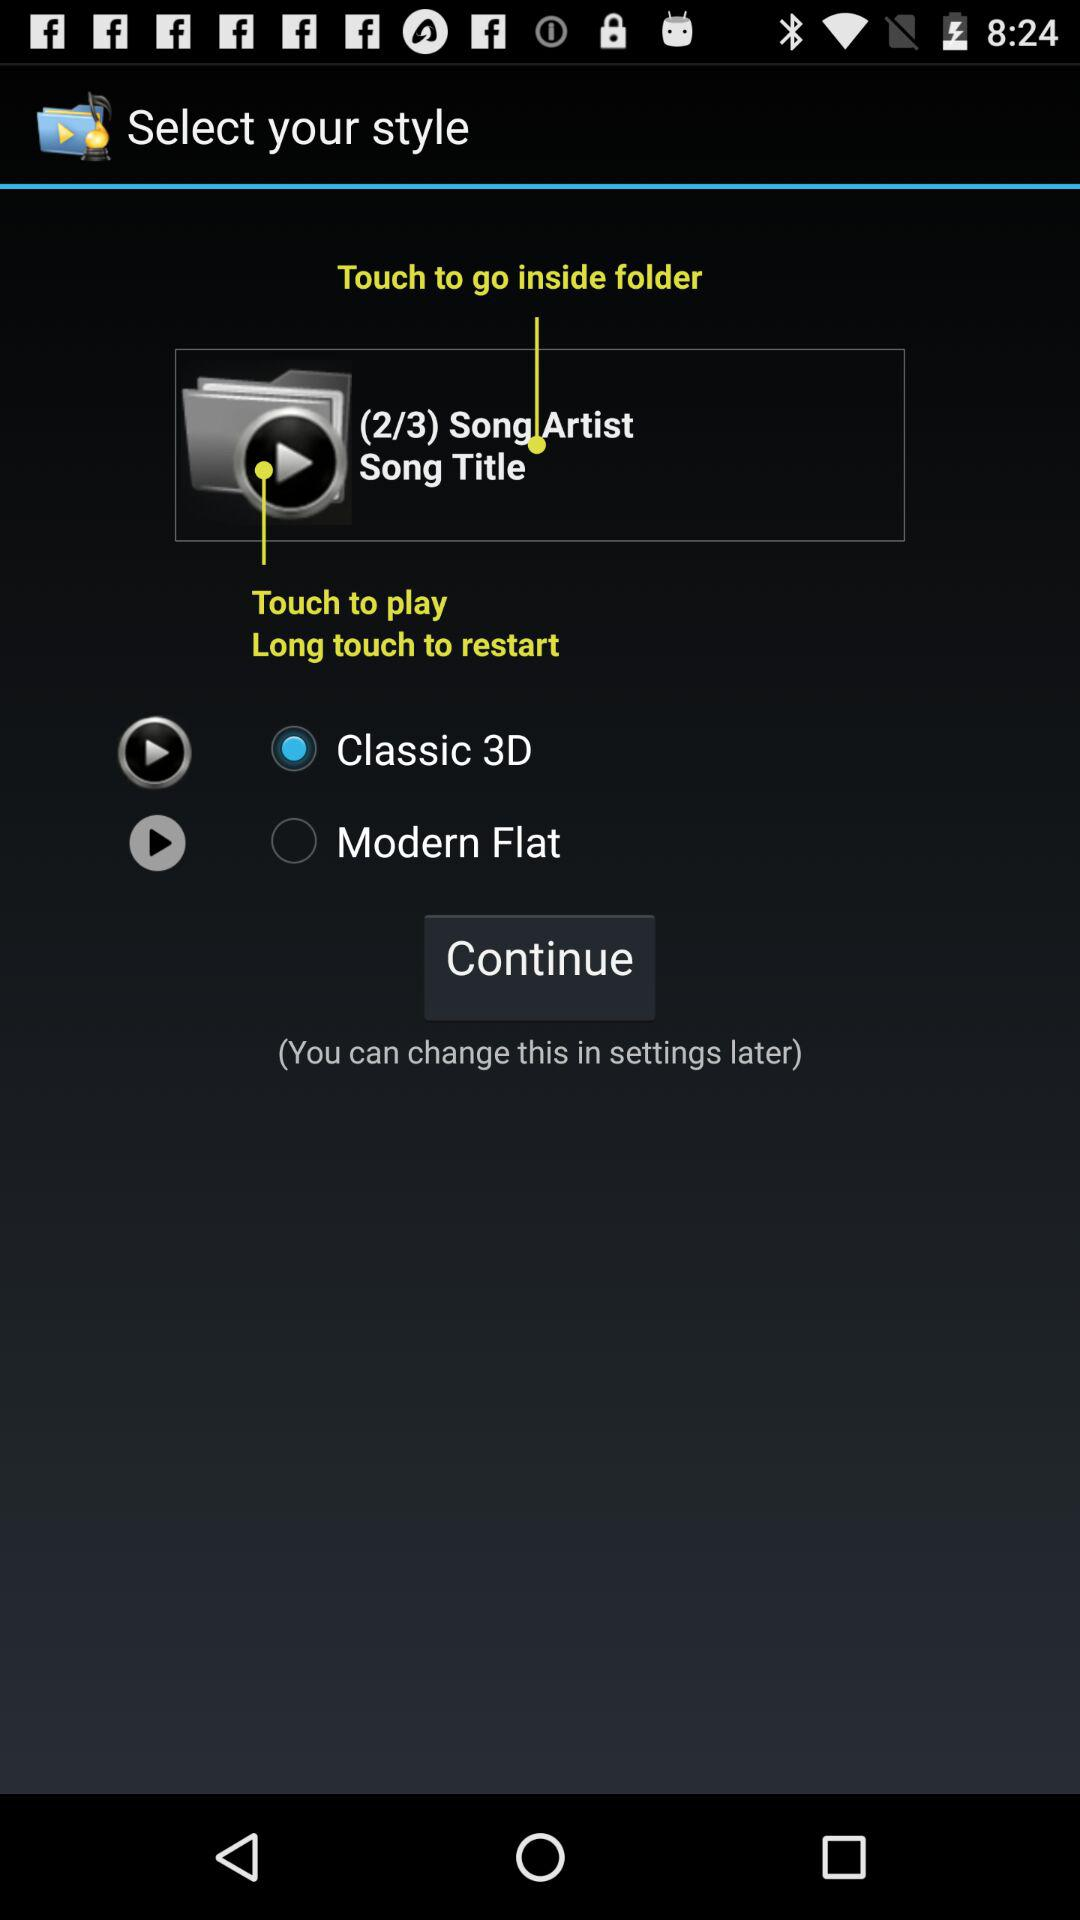How many songwriters are there in total?
When the provided information is insufficient, respond with <no answer>. <no answer> 